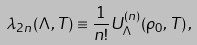<formula> <loc_0><loc_0><loc_500><loc_500>\lambda _ { 2 n } ( \Lambda , T ) \equiv \frac { 1 } { n ! } U _ { \Lambda } ^ { ( n ) } ( \rho _ { 0 } , T ) \, ,</formula> 